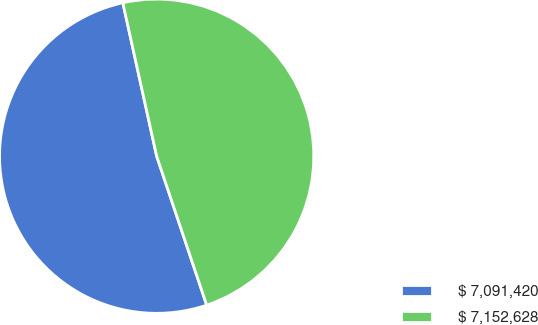<chart> <loc_0><loc_0><loc_500><loc_500><pie_chart><fcel>$ 7,091,420<fcel>$ 7,152,628<nl><fcel>51.7%<fcel>48.3%<nl></chart> 